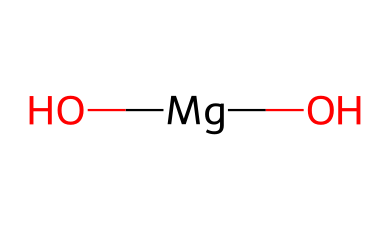How many magnesium atoms are in this structure? The SMILES notation shows a single magnesium atom represented by [Mg]. Therefore, there is only one magnesium atom in the chemical structure of magnesium hydroxide.
Answer: 1 How many hydroxide groups are present in magnesium hydroxide? The notation (O)(O) indicates two hydroxide groups (each hydroxide is represented by an oxygen atom in the structure connected to a magnesium atom). Thus, there are two hydroxide groups.
Answer: 2 What is the overall charge of the magnesium in this structure? Magnesium typically has a +2 oxidation state, depicted in the structure as being bonded to two hydroxide ions, which together are neutral. Thus, the charge on magnesium in this compound is +2.
Answer: +2 What kind of bond connects magnesium to the hydroxide ions? In this structure, magnesium forms ionic bonds with hydroxide, as magnesium donates electrons and hydroxide accepts them, leading to an ionic compound formation.
Answer: ionic Is magnesium hydroxide a strong or weak base? Magnesium hydroxide is considered a weak base because it does not completely dissociate in water, providing a less pronounced pH increase compared to strong bases like sodium hydroxide.
Answer: weak How does the molecular arrangement of magnesium hydroxide contribute to its function as an antacid? The molecular arrangement offers a way to interact with stomach acid (HCl); the presence of hydroxide ions allows them to neutralize excess acid, relieving indigestion and heartburn.
Answer: neutralizes acid 